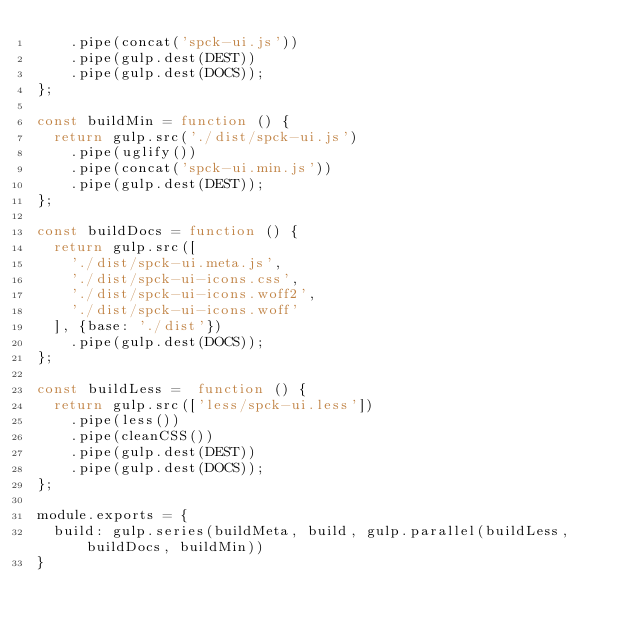Convert code to text. <code><loc_0><loc_0><loc_500><loc_500><_JavaScript_>    .pipe(concat('spck-ui.js'))
    .pipe(gulp.dest(DEST))
    .pipe(gulp.dest(DOCS));
};

const buildMin = function () {
  return gulp.src('./dist/spck-ui.js')
    .pipe(uglify())
    .pipe(concat('spck-ui.min.js'))
    .pipe(gulp.dest(DEST));
};

const buildDocs = function () {
  return gulp.src([
    './dist/spck-ui.meta.js',
    './dist/spck-ui-icons.css',
    './dist/spck-ui-icons.woff2',
    './dist/spck-ui-icons.woff'
  ], {base: './dist'})
    .pipe(gulp.dest(DOCS));
};

const buildLess =  function () {
  return gulp.src(['less/spck-ui.less'])
    .pipe(less())
    .pipe(cleanCSS())
    .pipe(gulp.dest(DEST))
    .pipe(gulp.dest(DOCS));
};

module.exports = {
  build: gulp.series(buildMeta, build, gulp.parallel(buildLess, buildDocs, buildMin))
}
</code> 